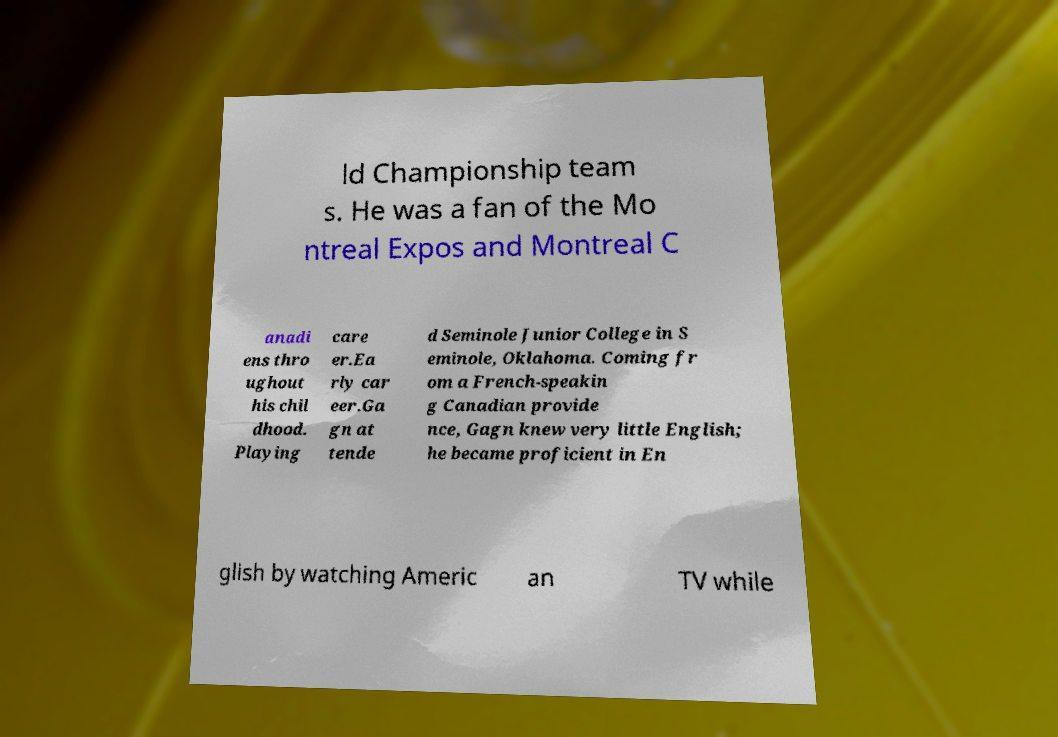Could you extract and type out the text from this image? ld Championship team s. He was a fan of the Mo ntreal Expos and Montreal C anadi ens thro ughout his chil dhood. Playing care er.Ea rly car eer.Ga gn at tende d Seminole Junior College in S eminole, Oklahoma. Coming fr om a French-speakin g Canadian provide nce, Gagn knew very little English; he became proficient in En glish by watching Americ an TV while 